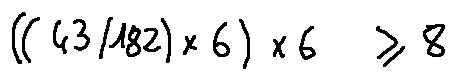Convert formula to latex. <formula><loc_0><loc_0><loc_500><loc_500>( ( 4 3 / 1 8 2 ) \times 6 ) \times 6 \geq 8</formula> 